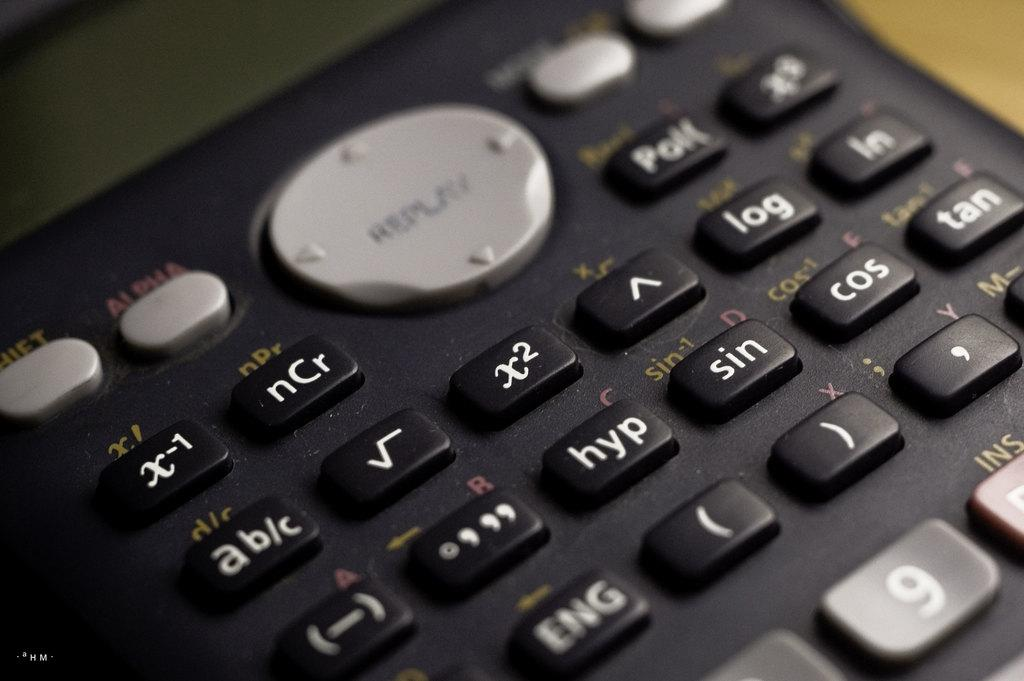Provide a one-sentence caption for the provided image. A keypad arrangementhas keys for nCr, hyp, sin and more. 